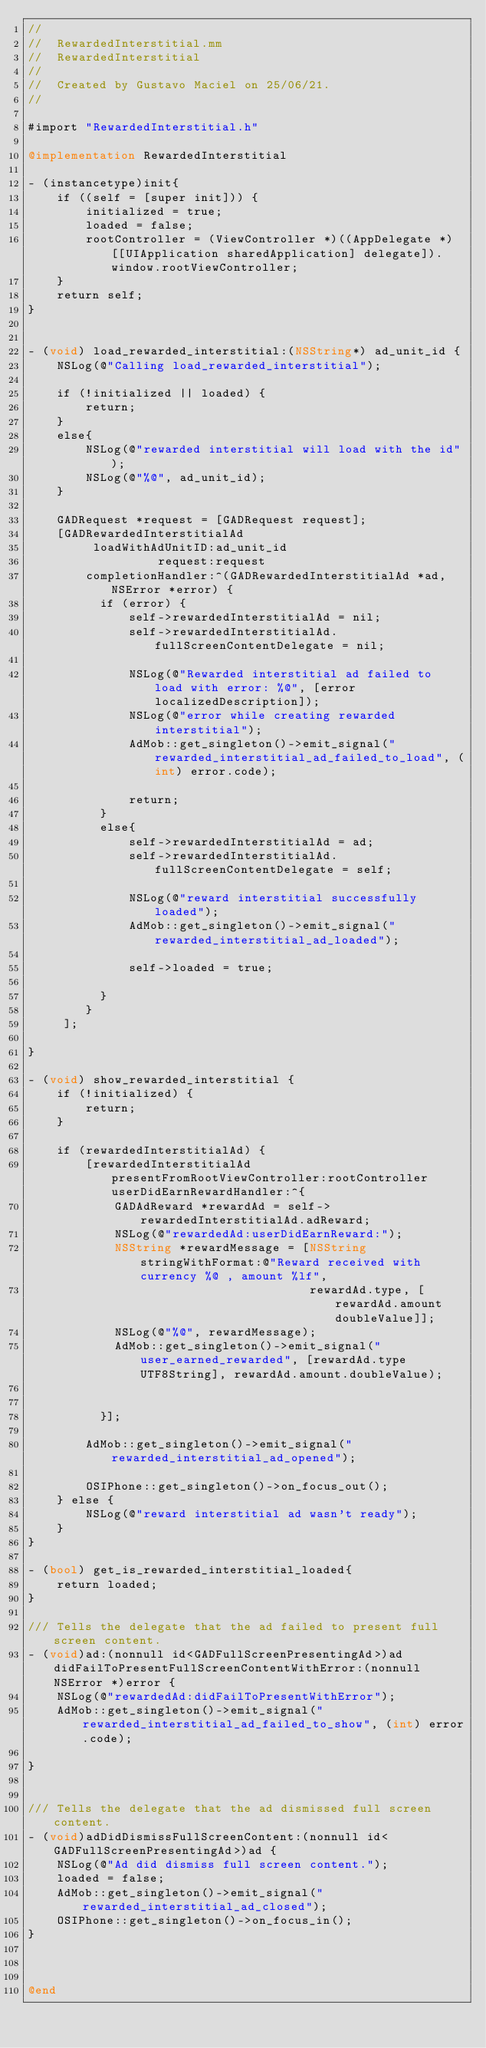<code> <loc_0><loc_0><loc_500><loc_500><_ObjectiveC_>//
//  RewardedInterstitial.mm
//  RewardedInterstitial
//
//  Created by Gustavo Maciel on 25/06/21.
//

#import "RewardedInterstitial.h"

@implementation RewardedInterstitial

- (instancetype)init{
    if ((self = [super init])) {
        initialized = true;
        loaded = false;
        rootController = (ViewController *)((AppDelegate *)[[UIApplication sharedApplication] delegate]).window.rootViewController;
    }
    return self;
}


- (void) load_rewarded_interstitial:(NSString*) ad_unit_id {
    NSLog(@"Calling load_rewarded_interstitial");
    
    if (!initialized || loaded) {
        return;
    }
    else{
        NSLog(@"rewarded interstitial will load with the id");
        NSLog(@"%@", ad_unit_id);
    }
        
    GADRequest *request = [GADRequest request];
    [GADRewardedInterstitialAd
         loadWithAdUnitID:ad_unit_id
                  request:request
        completionHandler:^(GADRewardedInterstitialAd *ad, NSError *error) {
          if (error) {
              self->rewardedInterstitialAd = nil;
              self->rewardedInterstitialAd.fullScreenContentDelegate = nil;

              NSLog(@"Rewarded interstitial ad failed to load with error: %@", [error localizedDescription]);
              NSLog(@"error while creating rewarded interstitial");
              AdMob::get_singleton()->emit_signal("rewarded_interstitial_ad_failed_to_load", (int) error.code);

              return;
          }
          else{
              self->rewardedInterstitialAd = ad;
              self->rewardedInterstitialAd.fullScreenContentDelegate = self;

              NSLog(@"reward interstitial successfully loaded");
              AdMob::get_singleton()->emit_signal("rewarded_interstitial_ad_loaded");

              self->loaded = true;

          }
        }
     ];
    
}

- (void) show_rewarded_interstitial {
    if (!initialized) {
        return;
    }
    
    if (rewardedInterstitialAd) {
        [rewardedInterstitialAd presentFromRootViewController:rootController userDidEarnRewardHandler:^{
            GADAdReward *rewardAd = self->rewardedInterstitialAd.adReward;
            NSLog(@"rewardedAd:userDidEarnReward:");
            NSString *rewardMessage = [NSString stringWithFormat:@"Reward received with currency %@ , amount %lf",
                                       rewardAd.type, [rewardAd.amount doubleValue]];
            NSLog(@"%@", rewardMessage);
            AdMob::get_singleton()->emit_signal("user_earned_rewarded", [rewardAd.type UTF8String], rewardAd.amount.doubleValue);


          }];

        AdMob::get_singleton()->emit_signal("rewarded_interstitial_ad_opened");

        OSIPhone::get_singleton()->on_focus_out();
    } else {
        NSLog(@"reward interstitial ad wasn't ready");
    }
}

- (bool) get_is_rewarded_interstitial_loaded{
    return loaded;
}

/// Tells the delegate that the ad failed to present full screen content.
- (void)ad:(nonnull id<GADFullScreenPresentingAd>)ad didFailToPresentFullScreenContentWithError:(nonnull NSError *)error {
    NSLog(@"rewardedAd:didFailToPresentWithError");
    AdMob::get_singleton()->emit_signal("rewarded_interstitial_ad_failed_to_show", (int) error.code);

}


/// Tells the delegate that the ad dismissed full screen content.
- (void)adDidDismissFullScreenContent:(nonnull id<GADFullScreenPresentingAd>)ad {
    NSLog(@"Ad did dismiss full screen content.");
    loaded = false;
    AdMob::get_singleton()->emit_signal("rewarded_interstitial_ad_closed");
    OSIPhone::get_singleton()->on_focus_in();
}



@end
</code> 